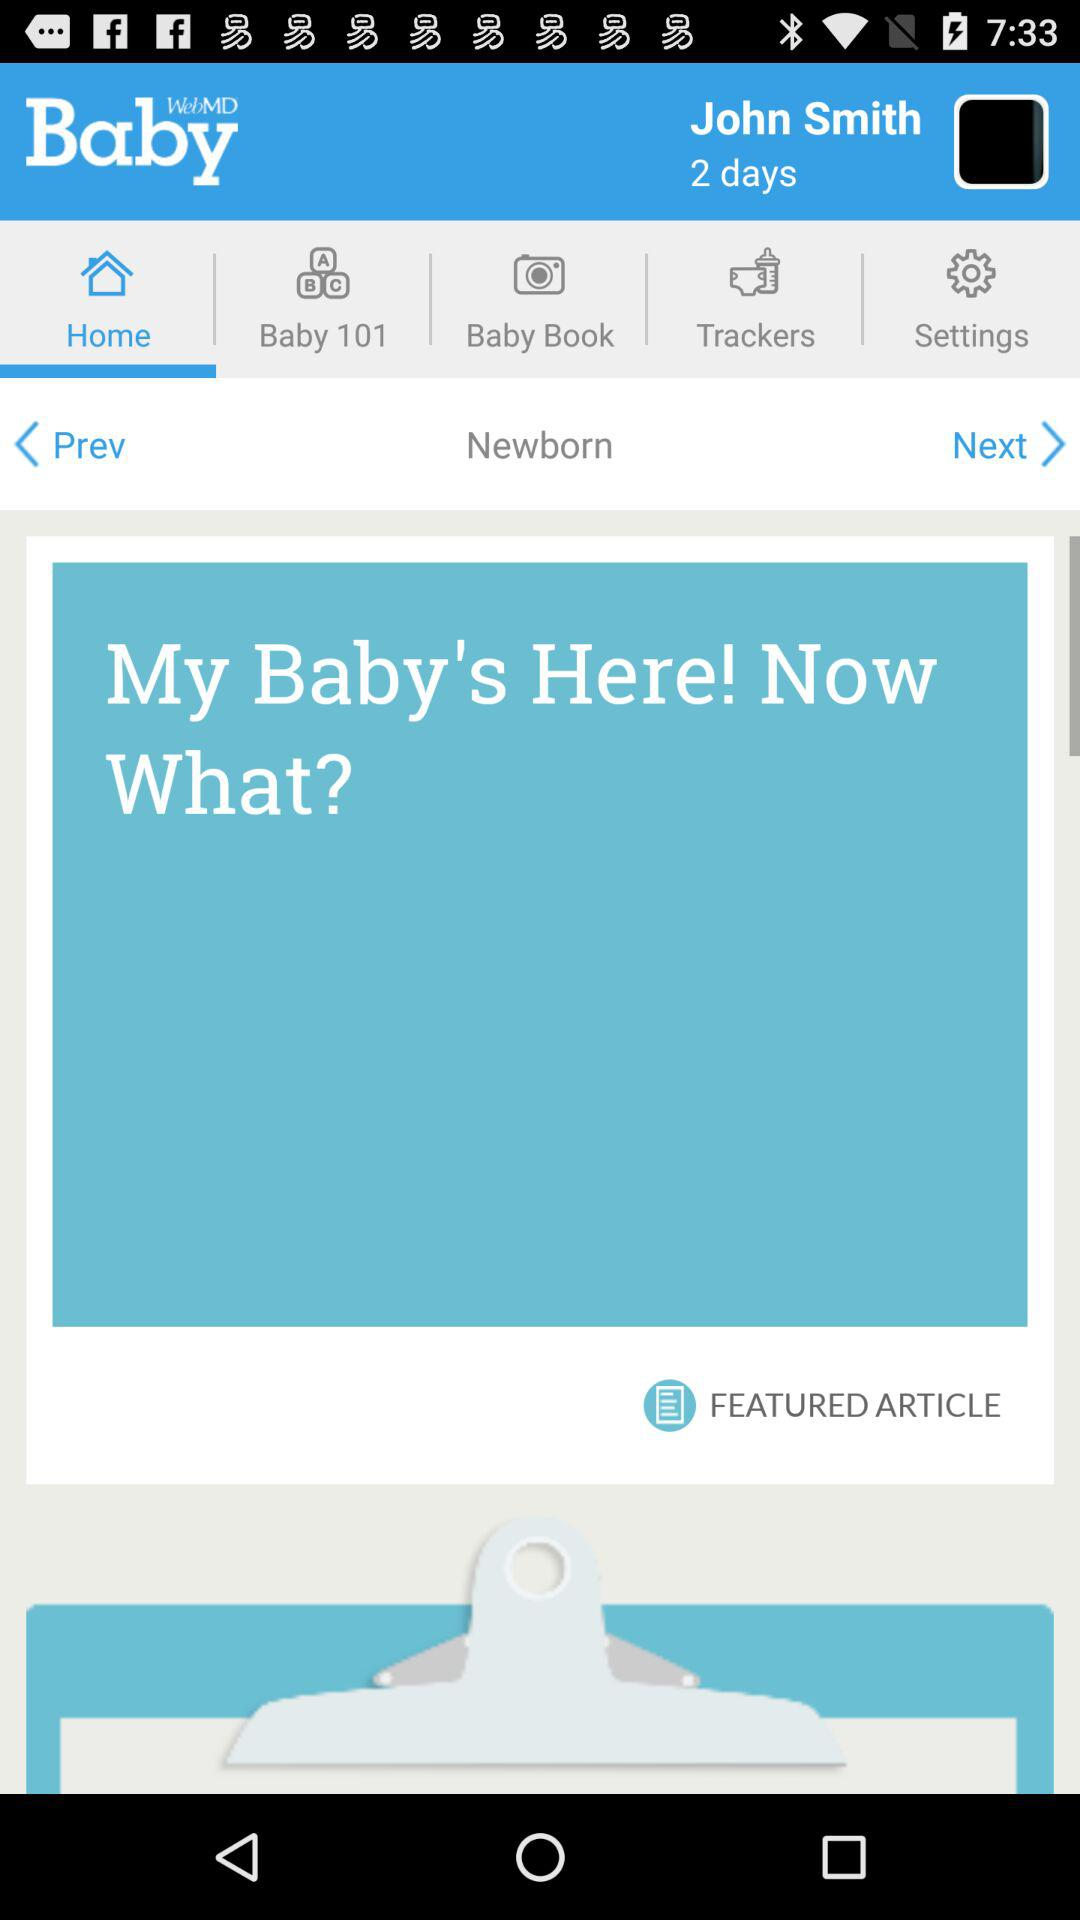What is the user's name? The user's name is John Smith. 